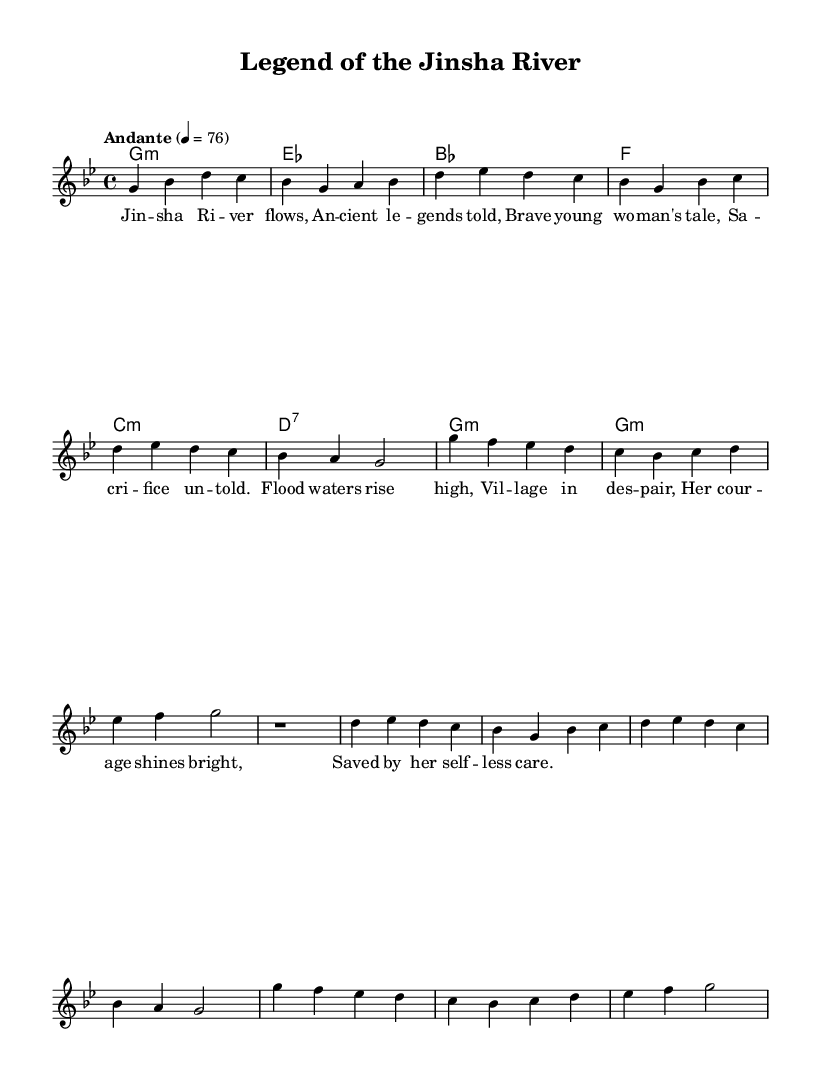What is the key signature of this music? The key signature is indicated in the global settings of the score, showing a flat symbol on the line four steps down from the tonic G. This means that it is G minor, which contains the accidentals for B flat and E flat.
Answer: G minor What is the time signature of this piece? The time signature is found in the global settings, indicating that it is divided into four beats per measure, with each quarter note receiving one beat. This is represented as 4/4.
Answer: 4/4 What is the tempo marking for this composition? The tempo marking is present in the global settings, stating "Andante" which indicates a moderately slow tempo, with a specific beats-per-minute (BPM) marking of 76.
Answer: Andante How many verses are included in this piece? By analyzing the structure of the music, the piece consists of two verses that are labeled as Verse 1 and Verse 2, each repeated in a shortened form.
Answer: 2 Verses What type of opera does this piece represent? The thematic focus of the lyrics and the title "Legend of the Jinsha River" suggests this piece embodies characteristics of Sichuan folk legends, typical of traditional Chinese operas.
Answer: Sichuan Opera What is the main theme addressed in the lyrics? The lyrics narrate a story about courage and sacrifice, symbolized by the "brave young woman's tale" amidst the flooding, indicating a heroic element aligned with Sichuan folklore.
Answer: Courage and sacrifice What is the structure of the piece as indicated in the score? The piece has an organized structure which alternates between melody and lyrics, featuring an introduction, verses, a chorus, and an interlude, denoting a clear progression typical in operatic works.
Answer: Introduction, Verses, Chorus, Interlude 